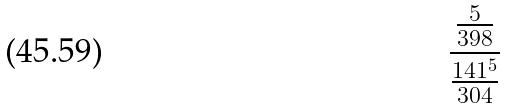<formula> <loc_0><loc_0><loc_500><loc_500>\frac { \frac { 5 } { 3 9 8 } } { \frac { 1 4 1 ^ { 5 } } { 3 0 4 } }</formula> 